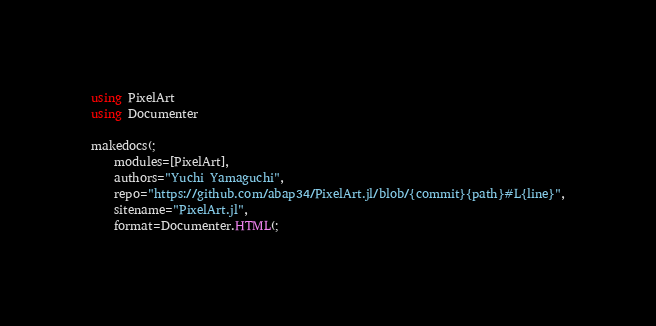Convert code to text. <code><loc_0><loc_0><loc_500><loc_500><_Julia_>using PixelArt
using Documenter

makedocs(;
    modules=[PixelArt],
    authors="Yuchi Yamaguchi",
    repo="https://github.com/abap34/PixelArt.jl/blob/{commit}{path}#L{line}",
    sitename="PixelArt.jl",
    format=Documenter.HTML(;</code> 